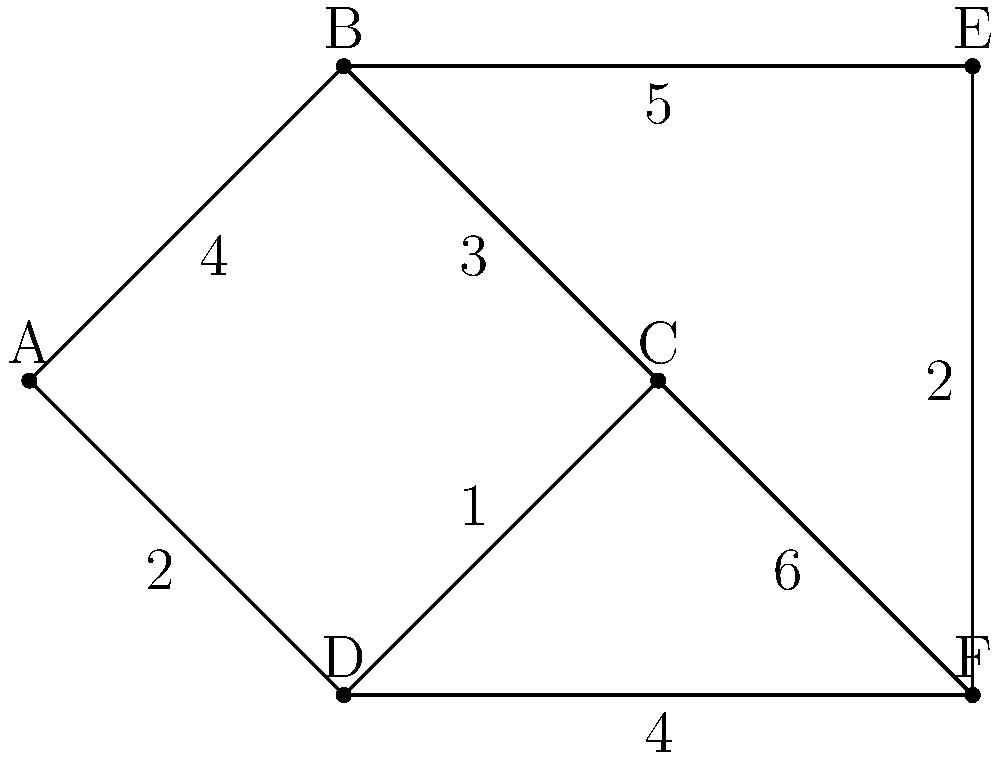As a software engineer in a Nigerian tech startup, you're tasked with optimizing the routing algorithm for a new ride-sharing application. Given the weighted graph above representing different locations in Lagos, what is the shortest path from node A to node F, and what is its total weight? To find the shortest path from A to F, we'll use Dijkstra's algorithm:

1. Initialize distances: A(0), B(∞), C(∞), D(∞), E(∞), F(∞)
2. Start from A:
   - Update B: min(∞, 0+4) = 4
   - Update D: min(∞, 0+2) = 2
3. Select D (smallest distance):
   - Update C: min(∞, 2+1) = 3
   - Update F: min(∞, 2+4) = 6
4. Select C:
   - Update B: min(4, 3+3) = 4 (no change)
   - Update F: min(6, 3+6) = 6 (no change)
5. Select B:
   - Update E: min(∞, 4+5) = 9
6. Select F (already reached, no updates)

The shortest path is A → D → C → F with a total weight of 6.
Answer: A → D → C → F, weight: 6 